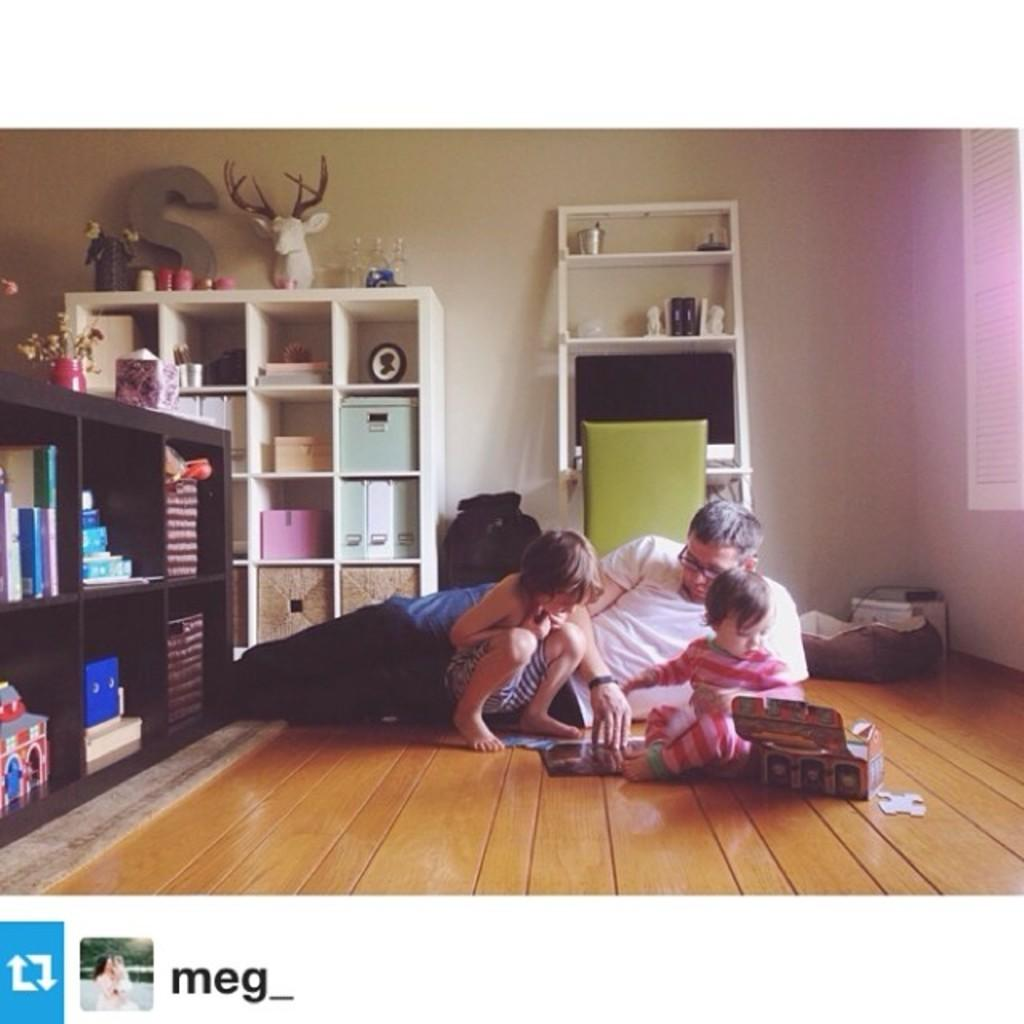<image>
Render a clear and concise summary of the photo. A man lays on the floor with two young children playing in a scene posted by Meg_. 